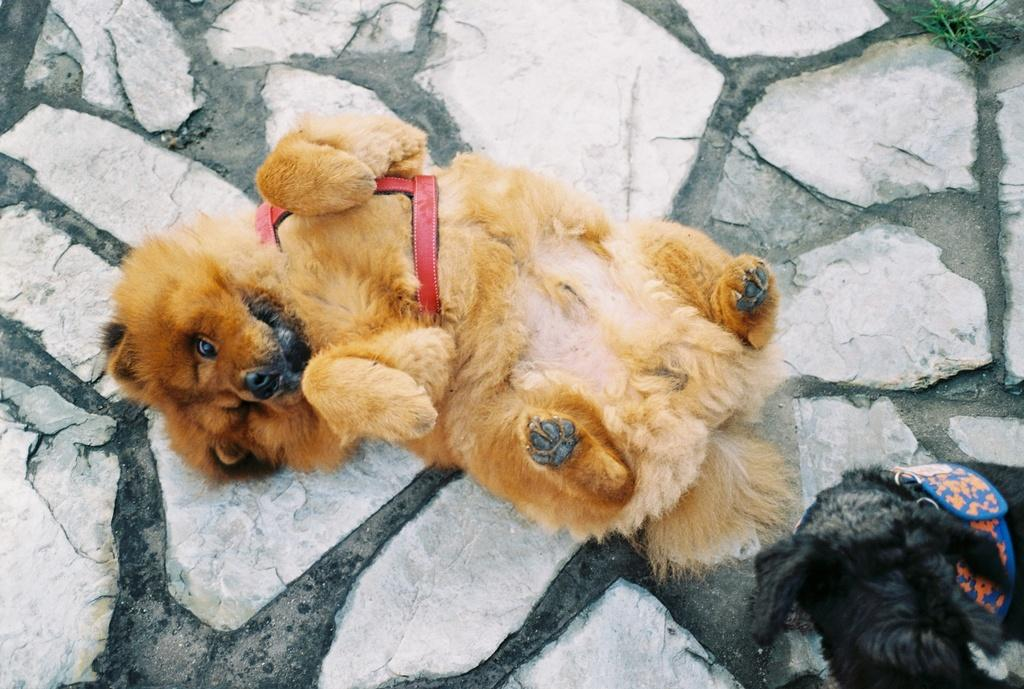How many dogs are present in the image? There are three dogs in the image. Where are the dogs located in the image? Two dogs are on the floor, and there is another black dog on the right side of the image. What is the profit margin of the cap worn by the black dog in the image? There is no cap worn by any dog in the image, and therefore no profit margin can be determined. 